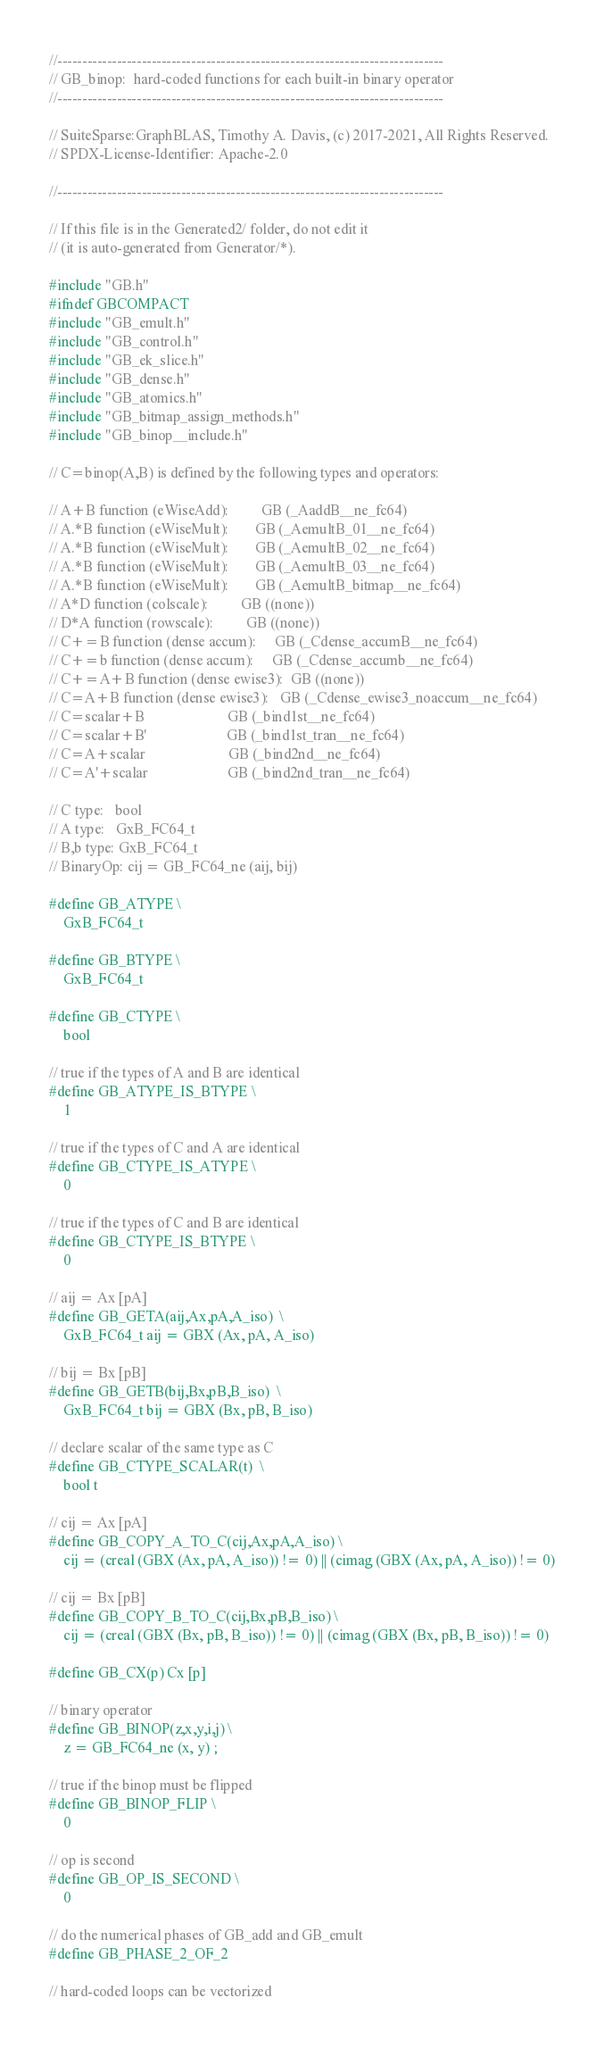<code> <loc_0><loc_0><loc_500><loc_500><_C_>//------------------------------------------------------------------------------
// GB_binop:  hard-coded functions for each built-in binary operator
//------------------------------------------------------------------------------

// SuiteSparse:GraphBLAS, Timothy A. Davis, (c) 2017-2021, All Rights Reserved.
// SPDX-License-Identifier: Apache-2.0

//------------------------------------------------------------------------------

// If this file is in the Generated2/ folder, do not edit it
// (it is auto-generated from Generator/*).

#include "GB.h"
#ifndef GBCOMPACT
#include "GB_emult.h"
#include "GB_control.h"
#include "GB_ek_slice.h"
#include "GB_dense.h"
#include "GB_atomics.h"
#include "GB_bitmap_assign_methods.h"
#include "GB_binop__include.h"

// C=binop(A,B) is defined by the following types and operators:

// A+B function (eWiseAdd):         GB (_AaddB__ne_fc64)
// A.*B function (eWiseMult):       GB (_AemultB_01__ne_fc64)
// A.*B function (eWiseMult):       GB (_AemultB_02__ne_fc64)
// A.*B function (eWiseMult):       GB (_AemultB_03__ne_fc64)
// A.*B function (eWiseMult):       GB (_AemultB_bitmap__ne_fc64)
// A*D function (colscale):         GB ((none))
// D*A function (rowscale):         GB ((none))
// C+=B function (dense accum):     GB (_Cdense_accumB__ne_fc64)
// C+=b function (dense accum):     GB (_Cdense_accumb__ne_fc64)
// C+=A+B function (dense ewise3):  GB ((none))
// C=A+B function (dense ewise3):   GB (_Cdense_ewise3_noaccum__ne_fc64)
// C=scalar+B                       GB (_bind1st__ne_fc64)
// C=scalar+B'                      GB (_bind1st_tran__ne_fc64)
// C=A+scalar                       GB (_bind2nd__ne_fc64)
// C=A'+scalar                      GB (_bind2nd_tran__ne_fc64)

// C type:   bool
// A type:   GxB_FC64_t
// B,b type: GxB_FC64_t
// BinaryOp: cij = GB_FC64_ne (aij, bij)

#define GB_ATYPE \
    GxB_FC64_t

#define GB_BTYPE \
    GxB_FC64_t

#define GB_CTYPE \
    bool

// true if the types of A and B are identical
#define GB_ATYPE_IS_BTYPE \
    1

// true if the types of C and A are identical
#define GB_CTYPE_IS_ATYPE \
    0

// true if the types of C and B are identical
#define GB_CTYPE_IS_BTYPE \
    0

// aij = Ax [pA]
#define GB_GETA(aij,Ax,pA,A_iso)  \
    GxB_FC64_t aij = GBX (Ax, pA, A_iso)

// bij = Bx [pB]
#define GB_GETB(bij,Bx,pB,B_iso)  \
    GxB_FC64_t bij = GBX (Bx, pB, B_iso)

// declare scalar of the same type as C
#define GB_CTYPE_SCALAR(t)  \
    bool t

// cij = Ax [pA]
#define GB_COPY_A_TO_C(cij,Ax,pA,A_iso) \
    cij = (creal (GBX (Ax, pA, A_iso)) != 0) || (cimag (GBX (Ax, pA, A_iso)) != 0)

// cij = Bx [pB]
#define GB_COPY_B_TO_C(cij,Bx,pB,B_iso) \
    cij = (creal (GBX (Bx, pB, B_iso)) != 0) || (cimag (GBX (Bx, pB, B_iso)) != 0)

#define GB_CX(p) Cx [p]

// binary operator
#define GB_BINOP(z,x,y,i,j) \
    z = GB_FC64_ne (x, y) ;

// true if the binop must be flipped
#define GB_BINOP_FLIP \
    0

// op is second
#define GB_OP_IS_SECOND \
    0

// do the numerical phases of GB_add and GB_emult
#define GB_PHASE_2_OF_2

// hard-coded loops can be vectorized</code> 